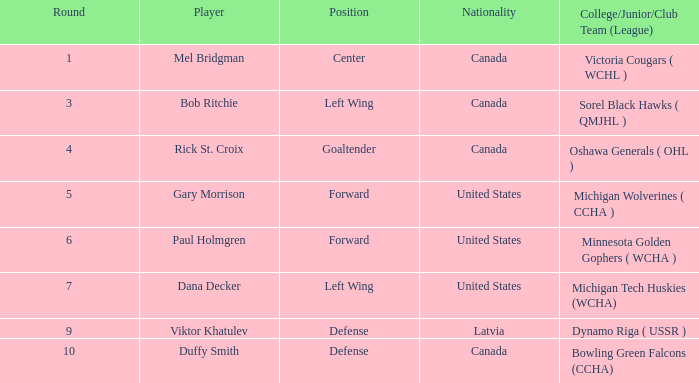Which Player has United States as Nationality, forward as Position and a greater than 5 Round? Paul Holmgren. 